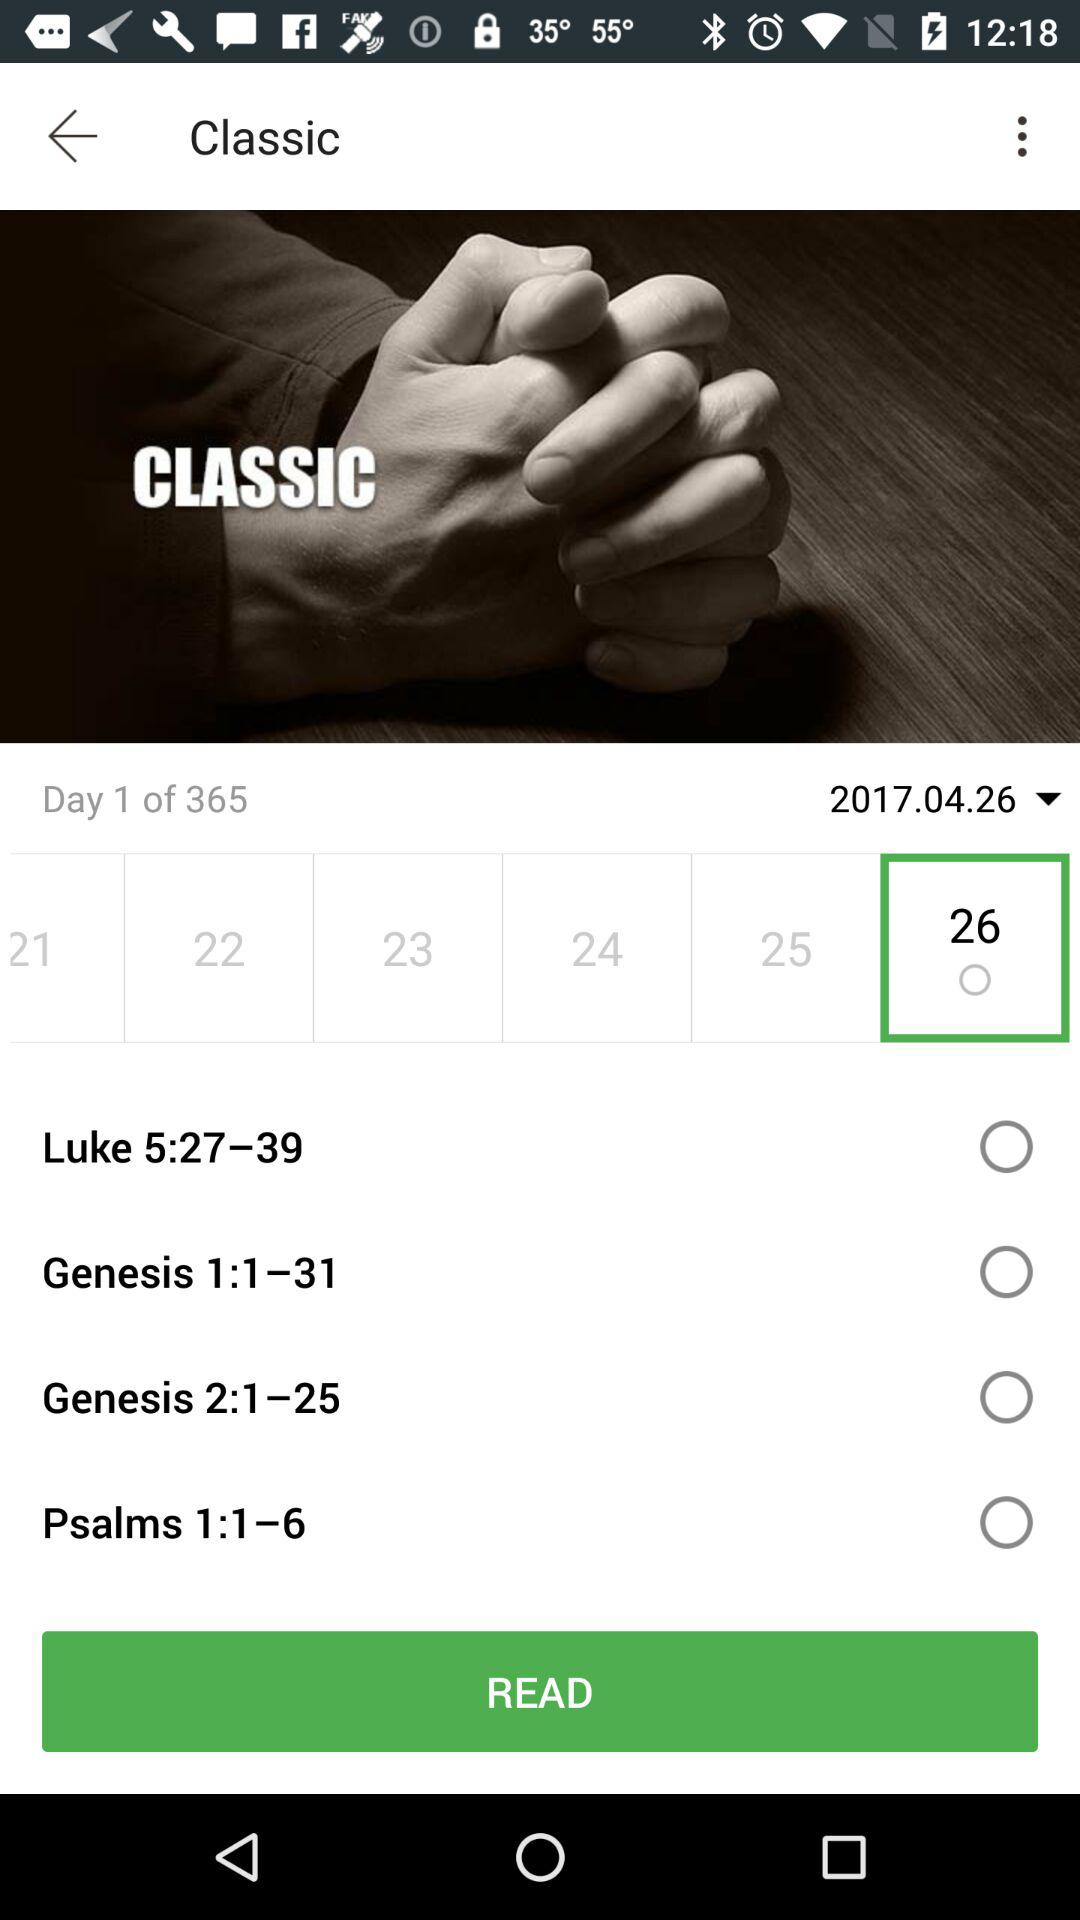On which day am I? You are on the first day. 